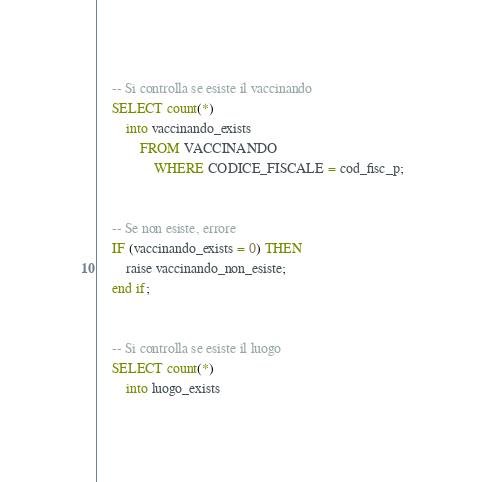<code> <loc_0><loc_0><loc_500><loc_500><_SQL_>    -- Si controlla se esiste il vaccinando
    SELECT count(*)
        into vaccinando_exists
            FROM VACCINANDO
                WHERE CODICE_FISCALE = cod_fisc_p;


    -- Se non esiste, errore
    IF (vaccinando_exists = 0) THEN
        raise vaccinando_non_esiste;
    end if;


    -- Si controlla se esiste il luogo
    SELECT count(*)
        into luogo_exists</code> 